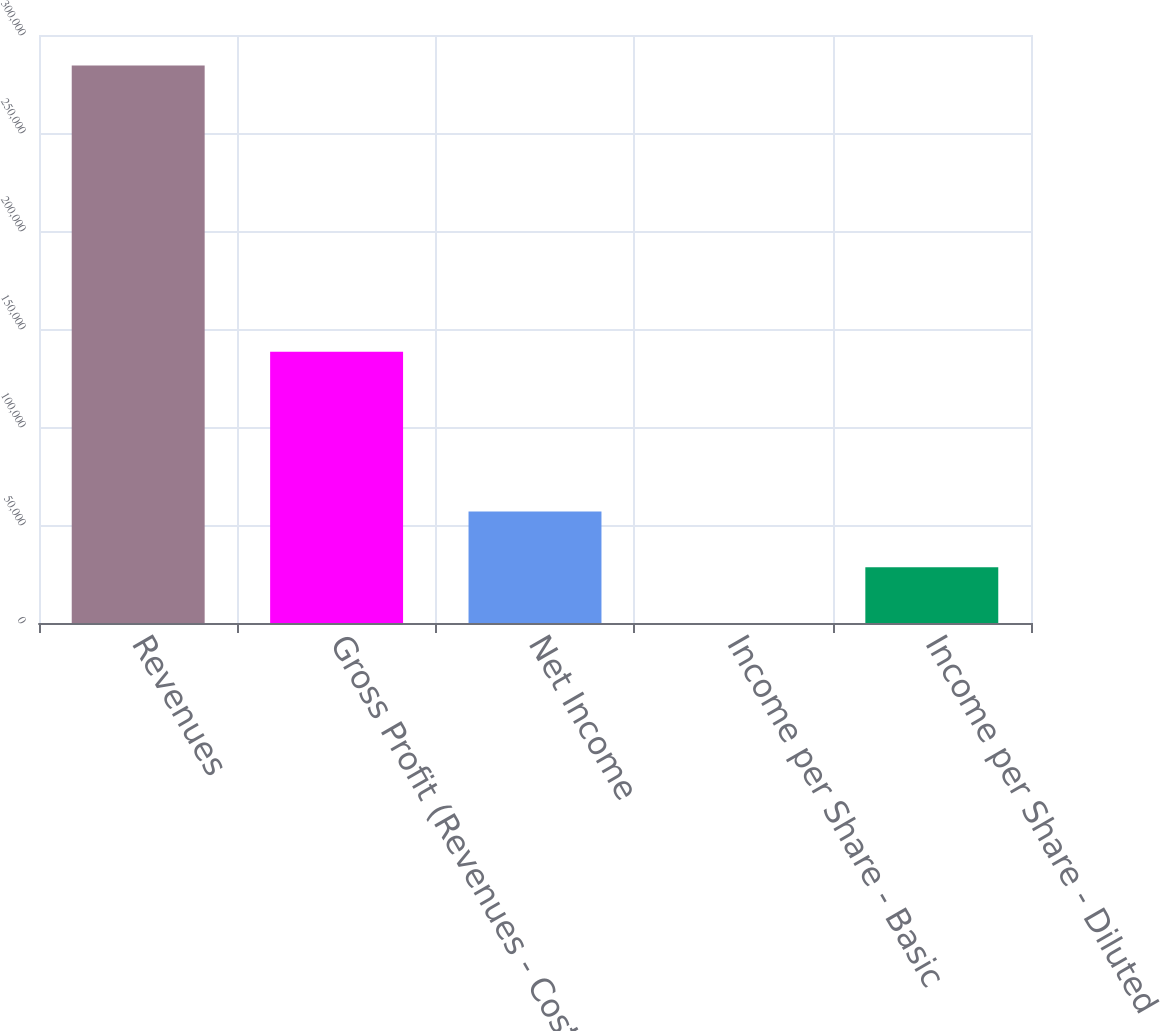<chart> <loc_0><loc_0><loc_500><loc_500><bar_chart><fcel>Revenues<fcel>Gross Profit (Revenues - Cost<fcel>Net Income<fcel>Income per Share - Basic<fcel>Income per Share - Diluted<nl><fcel>284499<fcel>138423<fcel>56900<fcel>0.23<fcel>28450.1<nl></chart> 